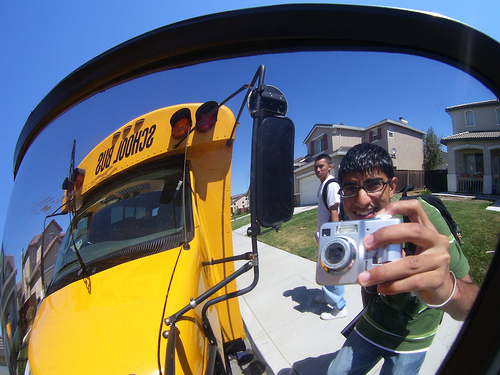Please provide a short description for this region: [0.39, 0.33, 0.43, 0.39]. This region shows the front headlight of a yellow school bus. 